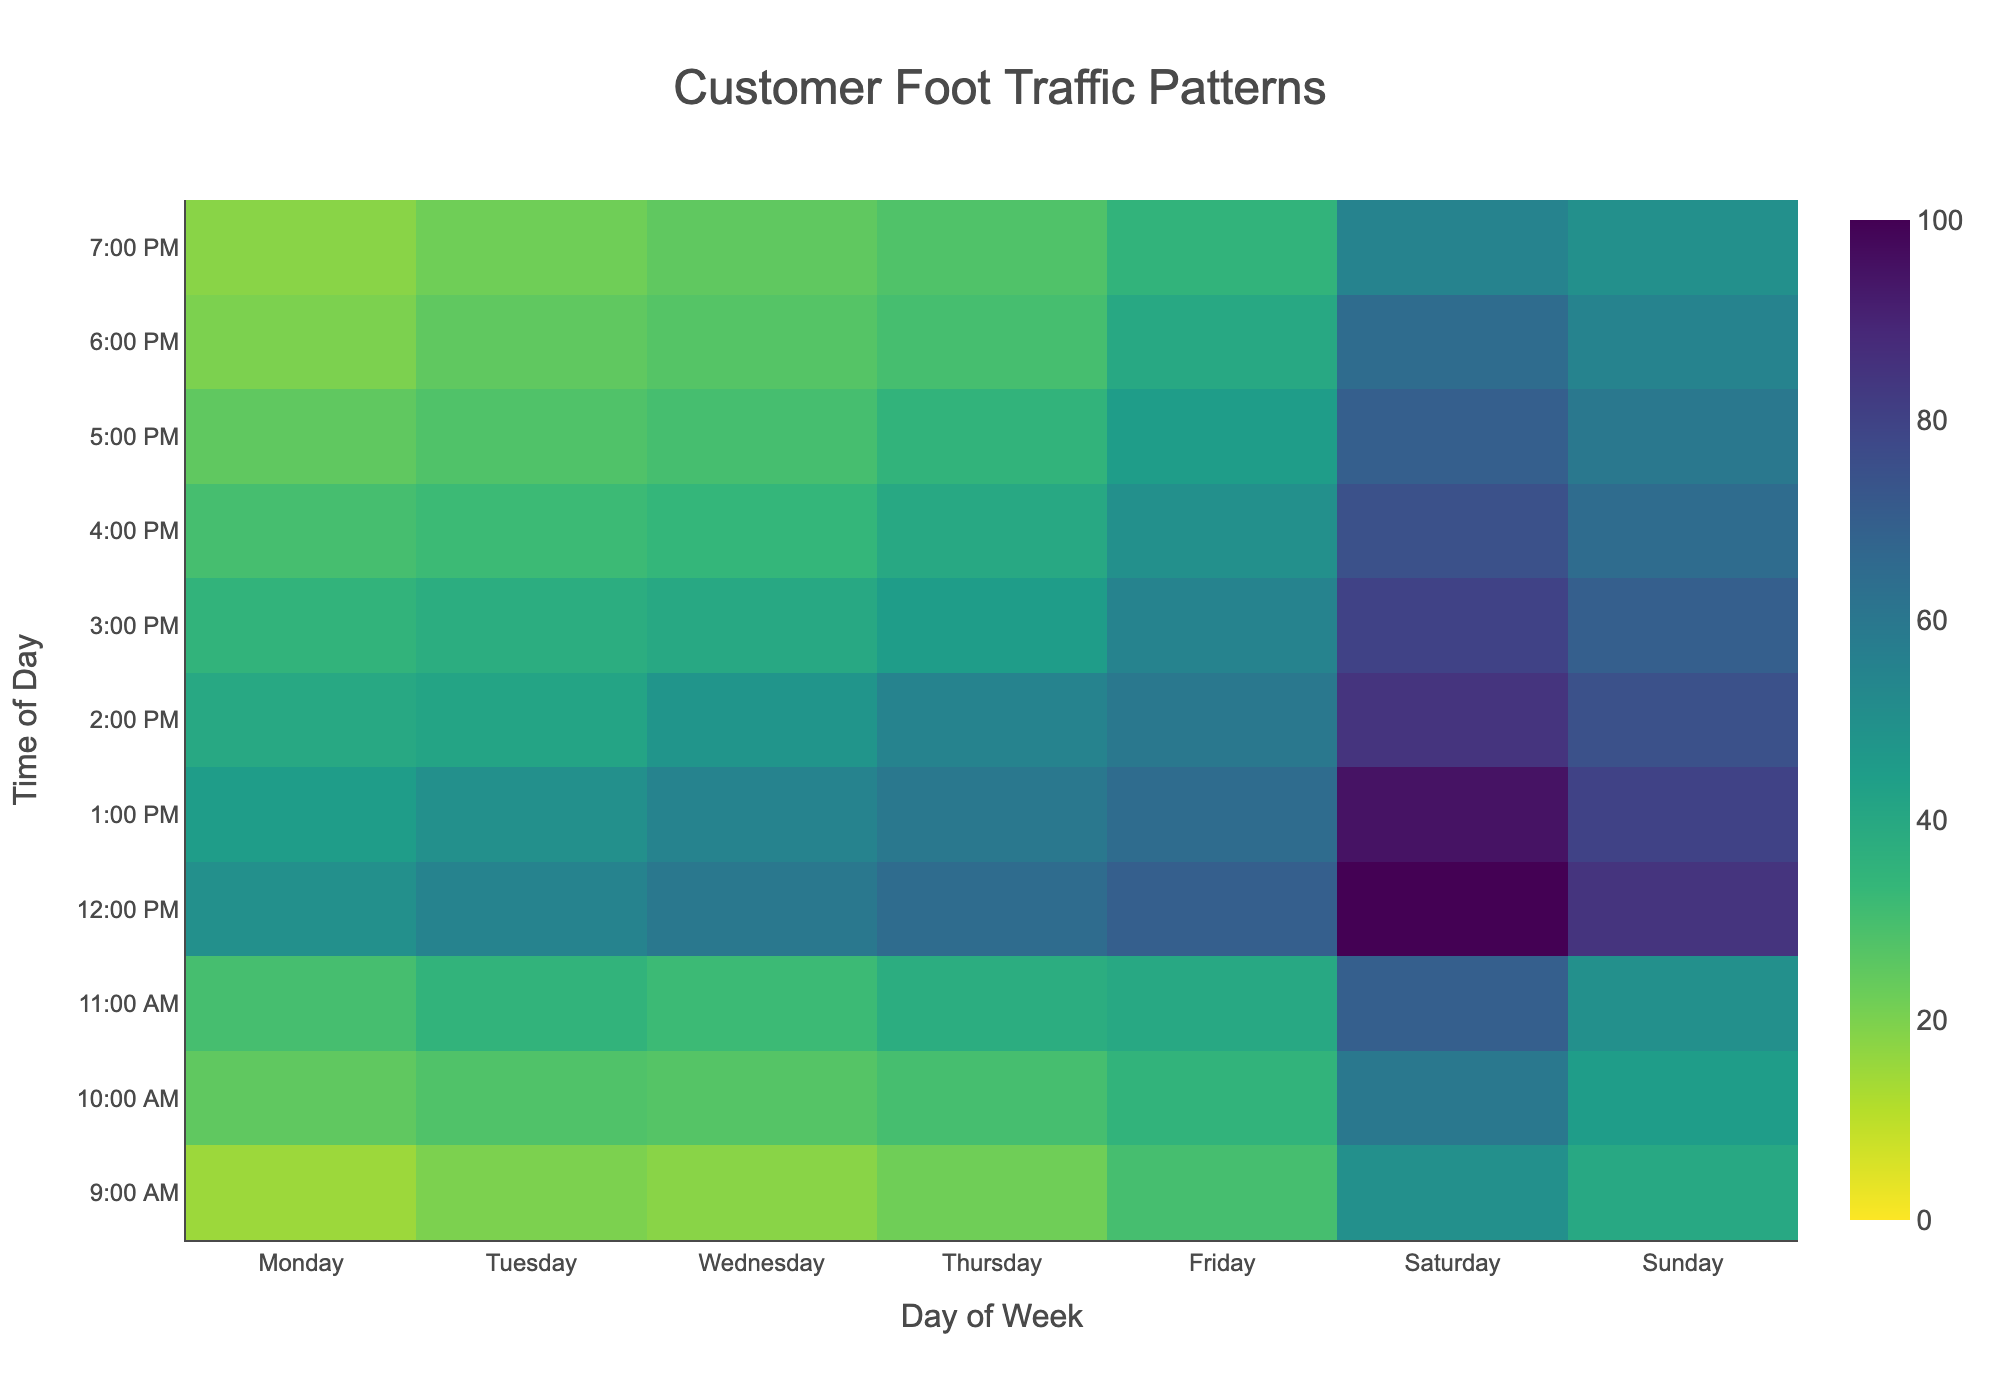what is the time of day with the highest foot traffic on Saturday? To find this, look at the column for Saturday and check which time of day has the highest value. The value 100 at 12:00 PM is the highest.
Answer: 12:00 PM Which day has the lowest foot traffic at 10:00 AM? To determine this, compare the values at 10:00 AM for each day. The value 25 on Monday is the lowest.
Answer: Monday What is the average foot traffic on Sundays from 12:00 PM to 3:00 PM? Sum up the foot traffic values on Sunday for 12:00 PM (85), 1:00 PM (80), 2:00 PM (75), and 3:00 PM (70). Divide by the number of time slots, which is 4. The sum is 310, and the average is 310/4 = 77.5.
Answer: 77.5 During which time slot is there a consistent increase in foot traffic from Monday to Friday? Look for a time slot where the values steadily increase from Monday to Friday. At 12:00 PM, foot traffic increases from 50 on Monday to 70 on Friday.
Answer: 12:00 PM How does foot traffic at 5:00 PM on Friday compare to the same time on Thursday? Check the values for 5:00 PM on Thursday (35) and Friday (45). The foot traffic on Friday is higher by 45 - 35 = 10.
Answer: Friday has 10 more What is the total foot traffic on Wednesday? Add all foot traffic values for Wednesday: 18 + 27 + 32 + 60 + 55 + 48 + 40 + 34 + 30 + 27 + 25 = 396.
Answer: 396 Which day has the highest variation in foot traffic throughout the day? Calculate the range (difference between max and min) for each day. Sunday has the highest variation with a range of 85 (highest 85 at 12:00 PM and lowest 40 at 9:00 AM, range is 85 - 40 = 45).
Answer: Sunday What is the least popular time of day on any day according to the heatmap? Find the lowest foot traffic value on the heatmap. The minimum value is 15 at 9:00 AM on Monday.
Answer: 9:00 AM on Monday 